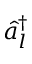<formula> <loc_0><loc_0><loc_500><loc_500>\hat { a } _ { l } ^ { \dagger }</formula> 